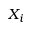<formula> <loc_0><loc_0><loc_500><loc_500>X _ { i }</formula> 